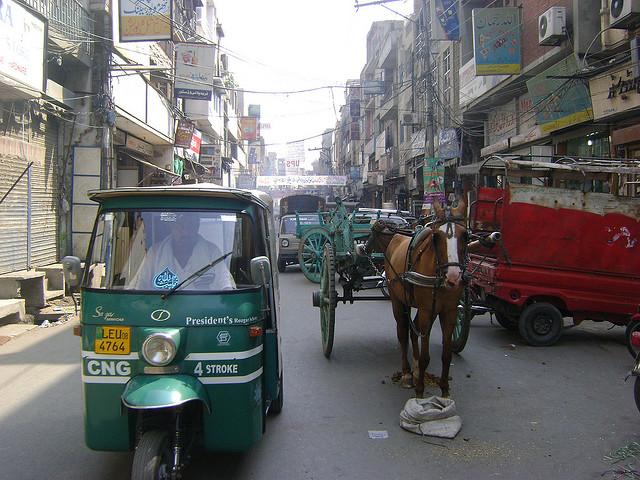What is the horse pulling?
Quick response, please. Carriage. Is this a two-way street?
Short answer required. No. What animal is in this picture?
Concise answer only. Horse. 